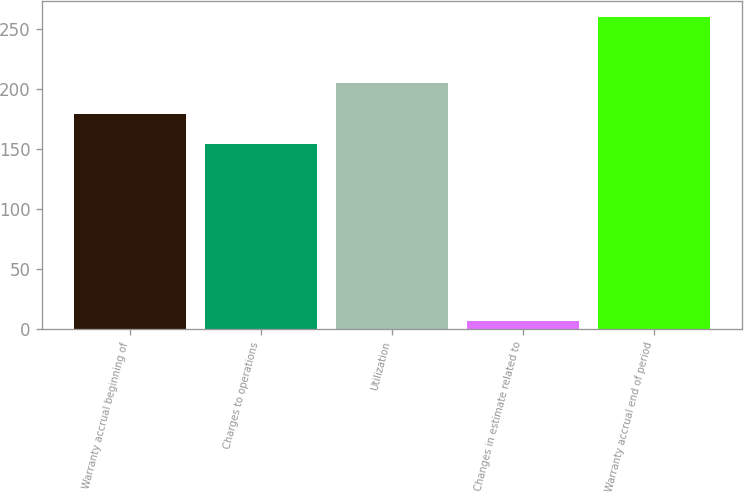Convert chart to OTSL. <chart><loc_0><loc_0><loc_500><loc_500><bar_chart><fcel>Warranty accrual beginning of<fcel>Charges to operations<fcel>Utilization<fcel>Changes in estimate related to<fcel>Warranty accrual end of period<nl><fcel>179.3<fcel>154<fcel>204.6<fcel>7<fcel>260<nl></chart> 